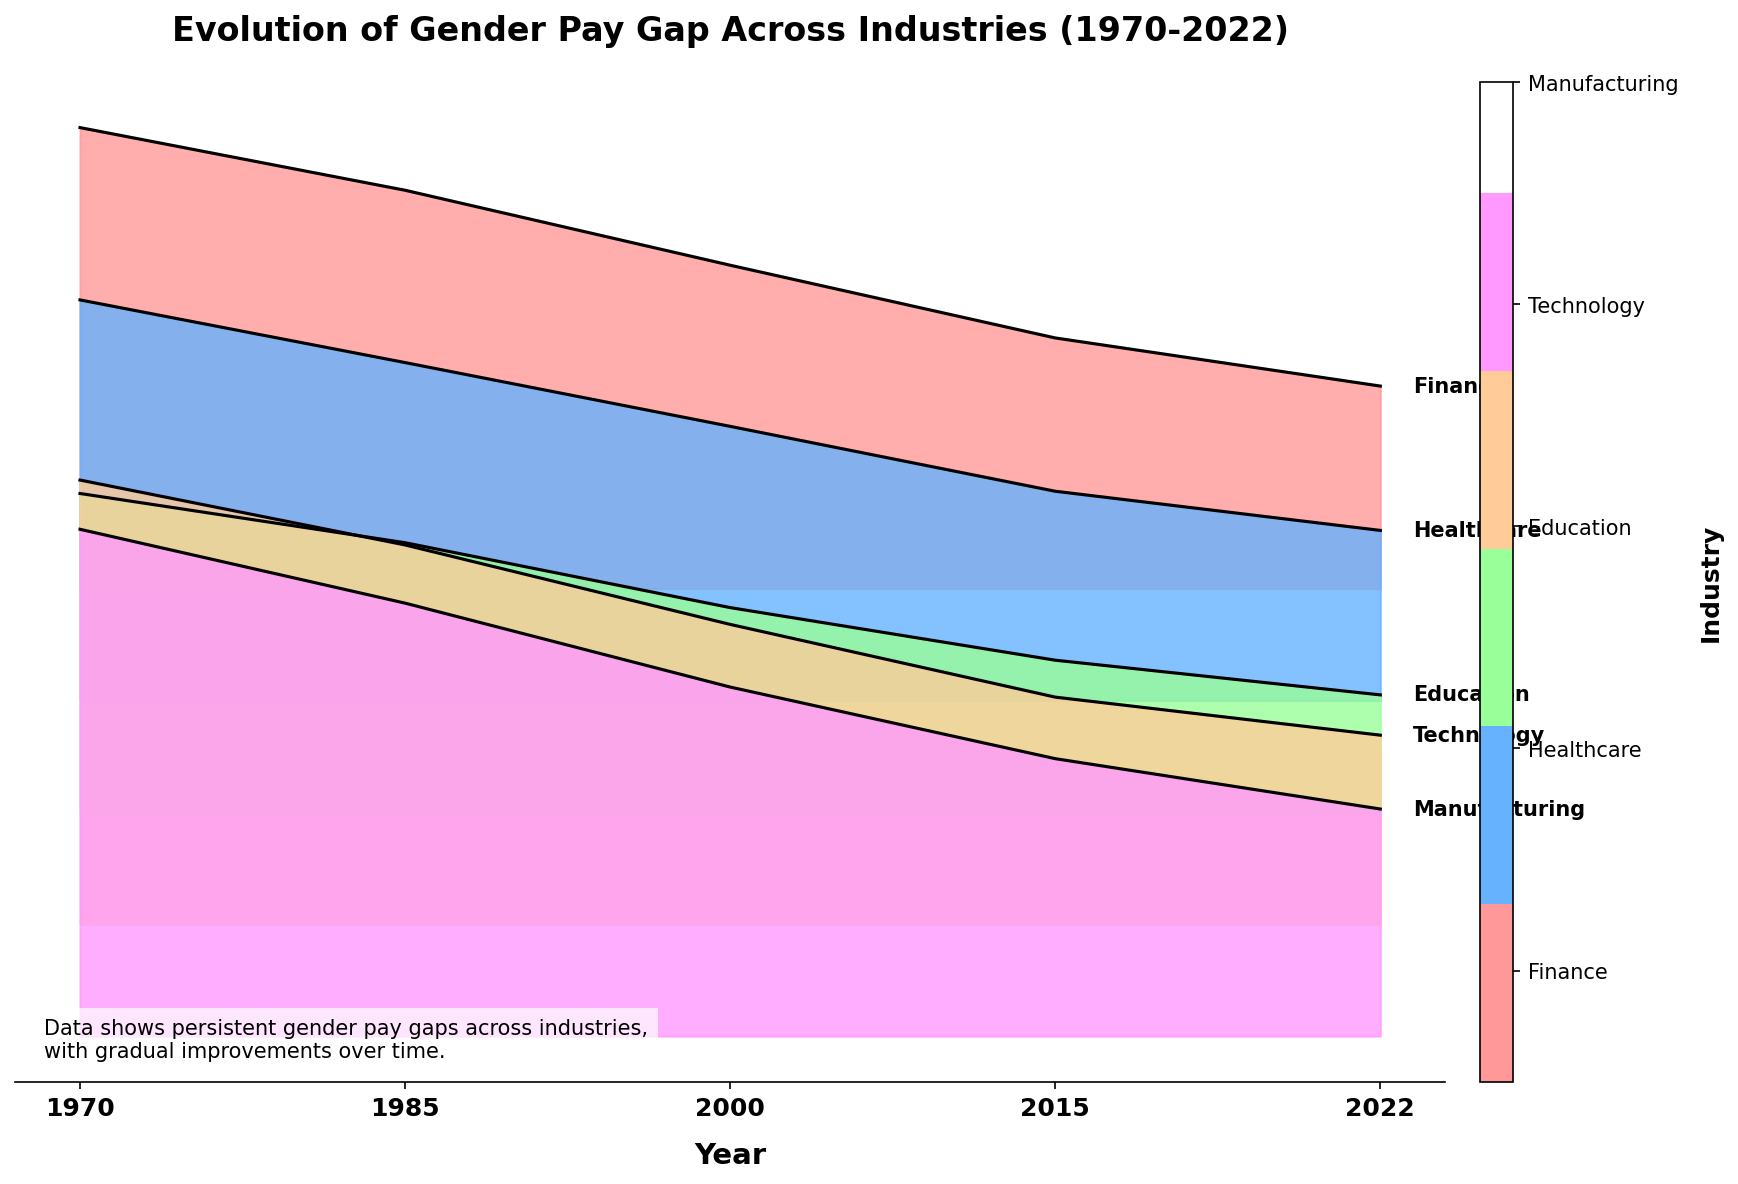What is the title of the plot? The title is the text at the top of the plot. In this case, the title reads "Evolution of Gender Pay Gap Across Industries (1970-2022)"
Answer: "Evolution of Gender Pay Gap Across Industries (1970-2022)" Which industry had the highest gender pay gap in 1970? To determine this, look at the lines and areas representing 1970 for each industry. The highest point in 1970 corresponds to Manufacturing.
Answer: Manufacturing What is the general trend in the gender pay gap from 1970 to 2022? Observe the trajectory of the lines for each industry from 1970 to 2022. Overall, the gaps have decreased, indicating an improvement.
Answer: Decrease How does the 2022 gender pay gap in Finance compare to that in Education? Look at the end points (2022) for both Finance and Education. The Finance gap is higher than Education in 2022.
Answer: Finance is higher Which industry showed the most significant reduction in gender pay gap from 1970 to 2022? Compare the starting and ending values for each industry. The one with the largest reduction is Education.
Answer: Education In which decade did Technology see the sharpest decline in gender pay gap? Identify the period with the steepest downward slope for Technology. The sharpest decline occurs between 2000 and 2015.
Answer: 2000 to 2015 What's the difference in gender pay gap for Healthcare between 1985 and 2000? Subtract the 2000 value for Healthcare from the 1985 value. 30.2 - 24.5 = 5.7.
Answer: 5.7 Which industry had the smallest gender pay gap in 2022? Find the industry with the lowest point in 2022. That's Education with 10.5%.
Answer: Education What was the gender pay gap in Manufacturing in 2015? Locate Manufacturing and look for its value in 2015. It's shown as 24.8%.
Answer: 24.8% How does the color mapping represent different industries? Notice the different color shades assigned to each industry in the legend and plot areas. Each unique color represents a specific industry.
Answer: Each unique color represents an industry 